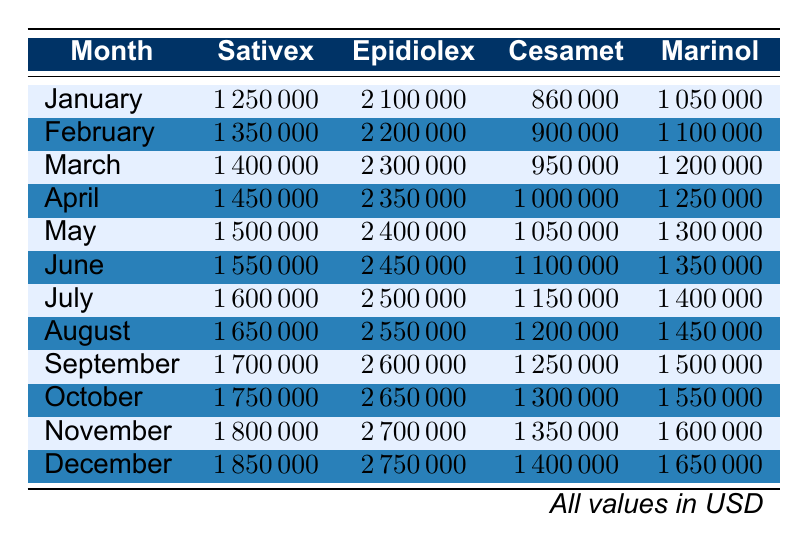What was the highest revenue generated by Epidiolex in 2023? The highest revenue for Epidiolex can be found by looking at the values in the Epidiolex column for each month. The values increase each month, with the last entry in December being the highest at 2,750,000.
Answer: 2,750,000 Which month generated the lowest revenue for Marinol? To find the lowest revenue for Marinol, we compare all the values in the Marinol column across the months. The lowest value is in January, which is 1,050,000.
Answer: 1,050,000 What is the total revenue from Sativex and Cesamet for the month of April? The revenue for Sativex in April is 1,450,000, and for Cesamet, it is 1,000,000. Adding these gives a total revenue of 1,450,000 + 1,000,000 = 2,450,000 for April.
Answer: 2,450,000 In which month did Cesamet reach a revenue of 1,300,000? Looking at the Cesamet column, it can be observed that the revenue for Cesamet equals 1,300,000 in October.
Answer: October Is the revenue from Sativex greater than that from Marinol in every month? By examining both the Sativex and Marinol columns for each month, Sativex's revenue is consistently higher than Marinol's revenue from January to December. This makes the statement true.
Answer: Yes What was the average monthly revenue for Epidiolex over the entire year 2023? To calculate the average monthly revenue for Epidiolex, first, we add up the monthly revenues: 2,100,000 + 2,200,000 + 2,300,000 + 2,350,000 + 2,400,000 + 2,450,000 + 2,500,000 + 2,550,000 + 2,600,000 + 2,650,000 + 2,700,000 + 2,750,000 = 29,400,000. There are 12 months, so we divide by 12 to get the average: 29,400,000 / 12 = 2,450,000.
Answer: 2,450,000 What was the change in revenue from Marinol between January and December? The revenue for Marinol in January is 1,050,000, and in December it is 1,650,000. To find the change, subtract January's revenue from December's: 1,650,000 - 1,050,000 = 600,000. Therefore, the change in revenue is an increase of 600,000.
Answer: 600,000 Which product had the greatest cumulative revenue over the first half of the year from January to June? To find which product had the highest cumulative revenue from January to June, we sum the revenues for each product over these months. For example, Sativex: 1,250,000 + 1,350,000 + 1,400,000 + 1,450,000 + 1,500,000 + 1,550,000 = 8,250,000, and similarly for the others. After calculating, Epidiolex has the highest cumulative revenue of 14,700,000 for those months.
Answer: Epidiolex Which month had the lowest total revenue across all products? To find the month with the lowest total revenue, we calculate the total revenue for each month by adding all product revenues. After performing the calculations, January has the lowest total revenue of 5,030,000.
Answer: January 